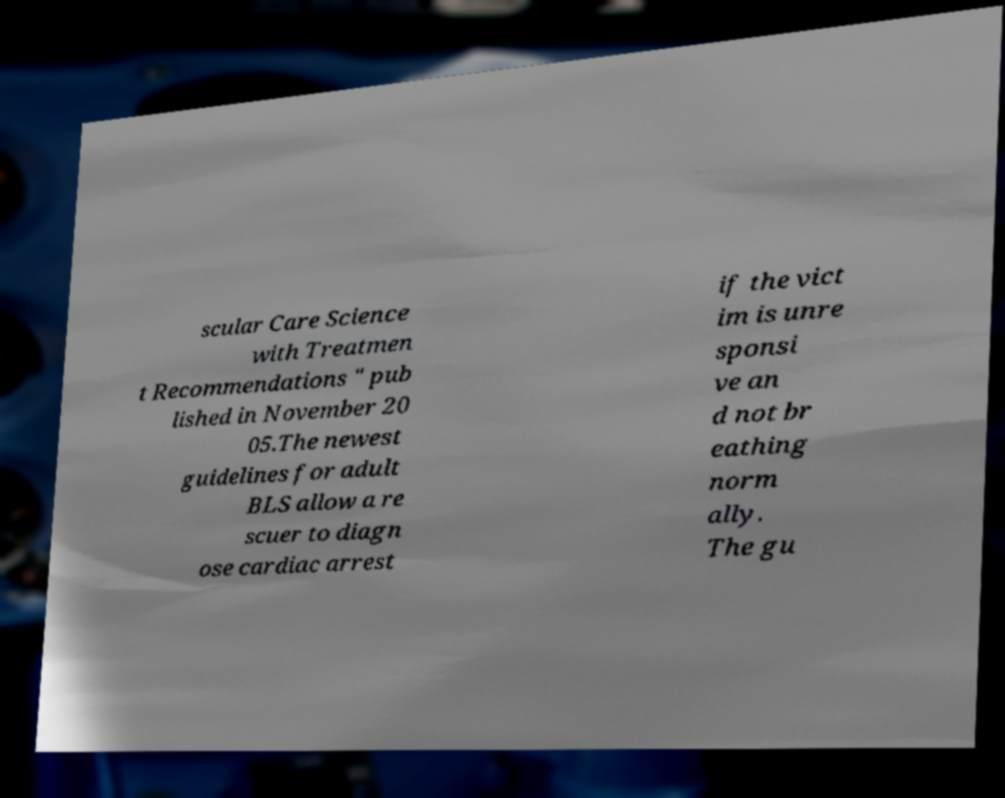Could you assist in decoding the text presented in this image and type it out clearly? scular Care Science with Treatmen t Recommendations " pub lished in November 20 05.The newest guidelines for adult BLS allow a re scuer to diagn ose cardiac arrest if the vict im is unre sponsi ve an d not br eathing norm ally. The gu 